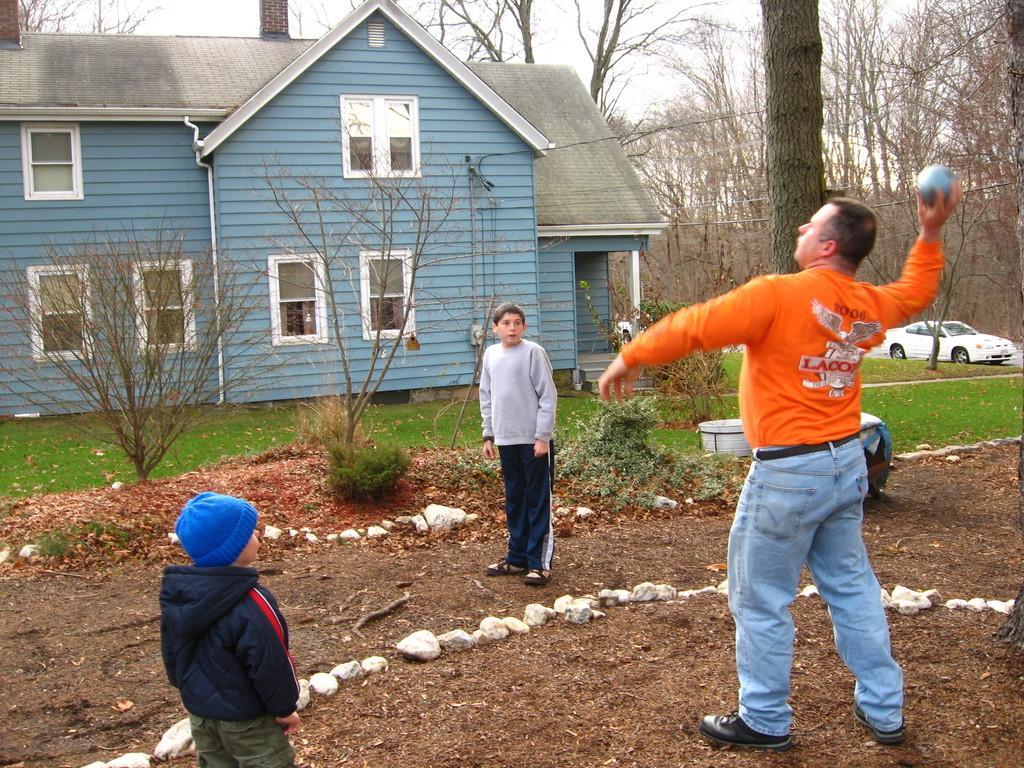How would you summarize this image in a sentence or two? In this image we can see two kids and one person are playing with a ball on the ground. On the left side of the image there is a house, in front of the house there are some trees and plants in the grass. In the background of the image there are dried trees and sky. 